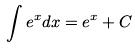Convert formula to latex. <formula><loc_0><loc_0><loc_500><loc_500>\int e ^ { x } d x = e ^ { x } + C</formula> 